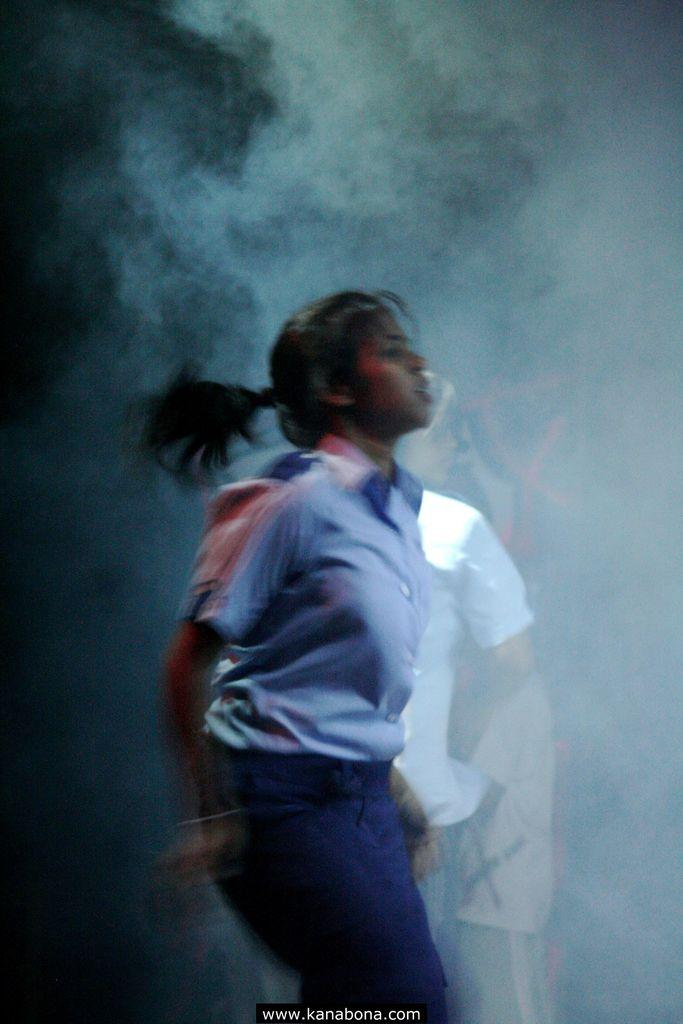What is the woman in the image wearing? The woman in the image is wearing a uniform. What information is displayed on the image? There is a website address on the image. What can be seen in the distance in the image? There are people in the background of the image. What is the presence of smoke in the image indicating? The presence of smoke in the image suggests that there may be some activity or event taking place. How many beds are visible in the image? There are no beds present in the image. What type of income can be earned from the activity depicted in the image? The image does not provide information about income or any activity related to earning money. 